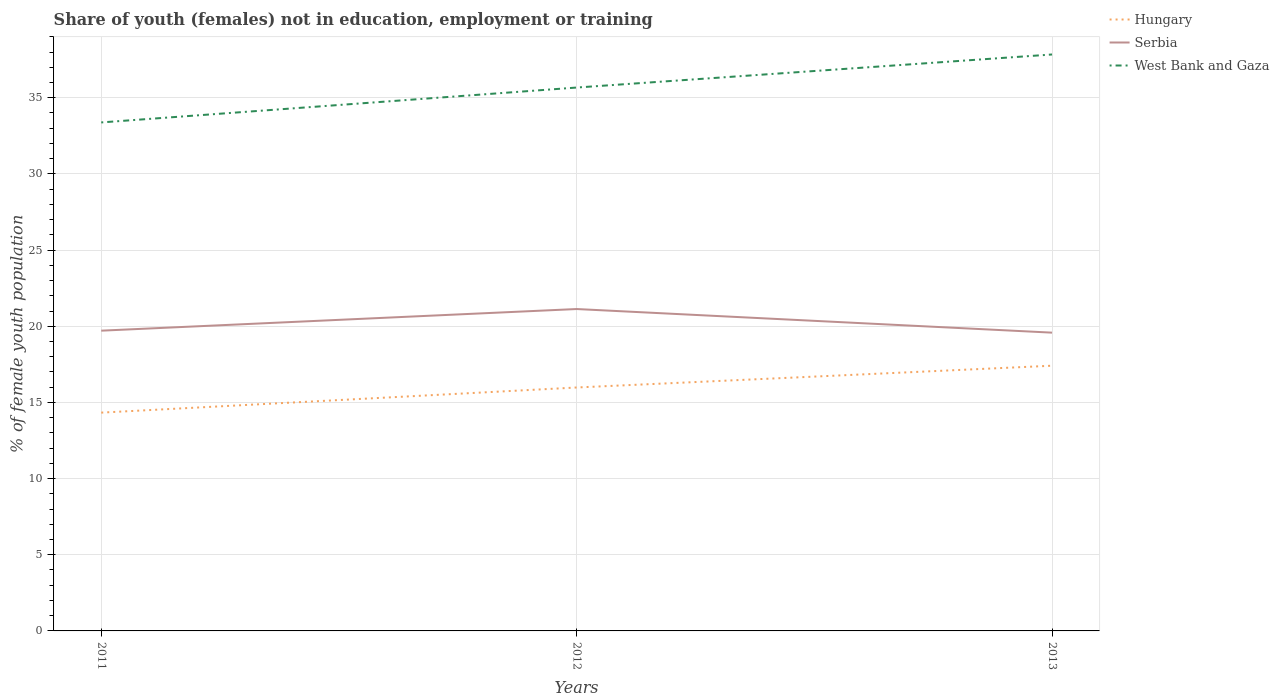How many different coloured lines are there?
Give a very brief answer. 3. Does the line corresponding to West Bank and Gaza intersect with the line corresponding to Serbia?
Provide a succinct answer. No. Across all years, what is the maximum percentage of unemployed female population in in West Bank and Gaza?
Offer a terse response. 33.38. In which year was the percentage of unemployed female population in in Hungary maximum?
Keep it short and to the point. 2011. What is the total percentage of unemployed female population in in Hungary in the graph?
Make the answer very short. -1.43. What is the difference between the highest and the second highest percentage of unemployed female population in in West Bank and Gaza?
Provide a succinct answer. 4.46. How many lines are there?
Your answer should be very brief. 3. How many years are there in the graph?
Your answer should be very brief. 3. What is the difference between two consecutive major ticks on the Y-axis?
Ensure brevity in your answer.  5. Are the values on the major ticks of Y-axis written in scientific E-notation?
Ensure brevity in your answer.  No. Where does the legend appear in the graph?
Offer a very short reply. Top right. How many legend labels are there?
Offer a terse response. 3. How are the legend labels stacked?
Provide a short and direct response. Vertical. What is the title of the graph?
Provide a short and direct response. Share of youth (females) not in education, employment or training. Does "China" appear as one of the legend labels in the graph?
Your answer should be very brief. No. What is the label or title of the Y-axis?
Your answer should be very brief. % of female youth population. What is the % of female youth population of Hungary in 2011?
Provide a succinct answer. 14.33. What is the % of female youth population in Serbia in 2011?
Make the answer very short. 19.71. What is the % of female youth population of West Bank and Gaza in 2011?
Make the answer very short. 33.38. What is the % of female youth population of Hungary in 2012?
Offer a very short reply. 15.98. What is the % of female youth population in Serbia in 2012?
Offer a terse response. 21.13. What is the % of female youth population in West Bank and Gaza in 2012?
Provide a succinct answer. 35.67. What is the % of female youth population of Hungary in 2013?
Provide a short and direct response. 17.41. What is the % of female youth population of Serbia in 2013?
Offer a terse response. 19.58. What is the % of female youth population in West Bank and Gaza in 2013?
Give a very brief answer. 37.84. Across all years, what is the maximum % of female youth population in Hungary?
Provide a short and direct response. 17.41. Across all years, what is the maximum % of female youth population of Serbia?
Your answer should be very brief. 21.13. Across all years, what is the maximum % of female youth population in West Bank and Gaza?
Provide a short and direct response. 37.84. Across all years, what is the minimum % of female youth population of Hungary?
Give a very brief answer. 14.33. Across all years, what is the minimum % of female youth population of Serbia?
Make the answer very short. 19.58. Across all years, what is the minimum % of female youth population in West Bank and Gaza?
Your response must be concise. 33.38. What is the total % of female youth population of Hungary in the graph?
Provide a short and direct response. 47.72. What is the total % of female youth population of Serbia in the graph?
Your answer should be very brief. 60.42. What is the total % of female youth population in West Bank and Gaza in the graph?
Provide a succinct answer. 106.89. What is the difference between the % of female youth population in Hungary in 2011 and that in 2012?
Give a very brief answer. -1.65. What is the difference between the % of female youth population of Serbia in 2011 and that in 2012?
Provide a succinct answer. -1.42. What is the difference between the % of female youth population of West Bank and Gaza in 2011 and that in 2012?
Ensure brevity in your answer.  -2.29. What is the difference between the % of female youth population of Hungary in 2011 and that in 2013?
Provide a succinct answer. -3.08. What is the difference between the % of female youth population of Serbia in 2011 and that in 2013?
Make the answer very short. 0.13. What is the difference between the % of female youth population in West Bank and Gaza in 2011 and that in 2013?
Your answer should be compact. -4.46. What is the difference between the % of female youth population in Hungary in 2012 and that in 2013?
Offer a very short reply. -1.43. What is the difference between the % of female youth population of Serbia in 2012 and that in 2013?
Give a very brief answer. 1.55. What is the difference between the % of female youth population of West Bank and Gaza in 2012 and that in 2013?
Your answer should be very brief. -2.17. What is the difference between the % of female youth population in Hungary in 2011 and the % of female youth population in West Bank and Gaza in 2012?
Provide a short and direct response. -21.34. What is the difference between the % of female youth population in Serbia in 2011 and the % of female youth population in West Bank and Gaza in 2012?
Your answer should be very brief. -15.96. What is the difference between the % of female youth population in Hungary in 2011 and the % of female youth population in Serbia in 2013?
Provide a succinct answer. -5.25. What is the difference between the % of female youth population in Hungary in 2011 and the % of female youth population in West Bank and Gaza in 2013?
Your answer should be compact. -23.51. What is the difference between the % of female youth population in Serbia in 2011 and the % of female youth population in West Bank and Gaza in 2013?
Provide a short and direct response. -18.13. What is the difference between the % of female youth population in Hungary in 2012 and the % of female youth population in West Bank and Gaza in 2013?
Give a very brief answer. -21.86. What is the difference between the % of female youth population of Serbia in 2012 and the % of female youth population of West Bank and Gaza in 2013?
Ensure brevity in your answer.  -16.71. What is the average % of female youth population in Hungary per year?
Offer a terse response. 15.91. What is the average % of female youth population in Serbia per year?
Your response must be concise. 20.14. What is the average % of female youth population of West Bank and Gaza per year?
Make the answer very short. 35.63. In the year 2011, what is the difference between the % of female youth population of Hungary and % of female youth population of Serbia?
Your answer should be very brief. -5.38. In the year 2011, what is the difference between the % of female youth population in Hungary and % of female youth population in West Bank and Gaza?
Your answer should be very brief. -19.05. In the year 2011, what is the difference between the % of female youth population in Serbia and % of female youth population in West Bank and Gaza?
Offer a very short reply. -13.67. In the year 2012, what is the difference between the % of female youth population in Hungary and % of female youth population in Serbia?
Your answer should be compact. -5.15. In the year 2012, what is the difference between the % of female youth population of Hungary and % of female youth population of West Bank and Gaza?
Give a very brief answer. -19.69. In the year 2012, what is the difference between the % of female youth population in Serbia and % of female youth population in West Bank and Gaza?
Ensure brevity in your answer.  -14.54. In the year 2013, what is the difference between the % of female youth population in Hungary and % of female youth population in Serbia?
Offer a very short reply. -2.17. In the year 2013, what is the difference between the % of female youth population of Hungary and % of female youth population of West Bank and Gaza?
Ensure brevity in your answer.  -20.43. In the year 2013, what is the difference between the % of female youth population in Serbia and % of female youth population in West Bank and Gaza?
Offer a terse response. -18.26. What is the ratio of the % of female youth population of Hungary in 2011 to that in 2012?
Your response must be concise. 0.9. What is the ratio of the % of female youth population of Serbia in 2011 to that in 2012?
Make the answer very short. 0.93. What is the ratio of the % of female youth population in West Bank and Gaza in 2011 to that in 2012?
Your answer should be very brief. 0.94. What is the ratio of the % of female youth population of Hungary in 2011 to that in 2013?
Keep it short and to the point. 0.82. What is the ratio of the % of female youth population of Serbia in 2011 to that in 2013?
Your response must be concise. 1.01. What is the ratio of the % of female youth population of West Bank and Gaza in 2011 to that in 2013?
Keep it short and to the point. 0.88. What is the ratio of the % of female youth population of Hungary in 2012 to that in 2013?
Make the answer very short. 0.92. What is the ratio of the % of female youth population in Serbia in 2012 to that in 2013?
Your answer should be very brief. 1.08. What is the ratio of the % of female youth population in West Bank and Gaza in 2012 to that in 2013?
Provide a short and direct response. 0.94. What is the difference between the highest and the second highest % of female youth population in Hungary?
Keep it short and to the point. 1.43. What is the difference between the highest and the second highest % of female youth population of Serbia?
Give a very brief answer. 1.42. What is the difference between the highest and the second highest % of female youth population in West Bank and Gaza?
Make the answer very short. 2.17. What is the difference between the highest and the lowest % of female youth population in Hungary?
Offer a terse response. 3.08. What is the difference between the highest and the lowest % of female youth population in Serbia?
Offer a very short reply. 1.55. What is the difference between the highest and the lowest % of female youth population in West Bank and Gaza?
Offer a terse response. 4.46. 